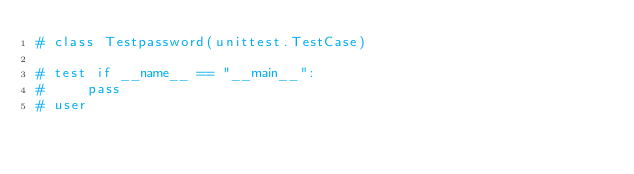Convert code to text. <code><loc_0><loc_0><loc_500><loc_500><_Python_># class Testpassword(unittest.TestCase)

# test if __name__ == "__main__":
#     pass
# user</code> 